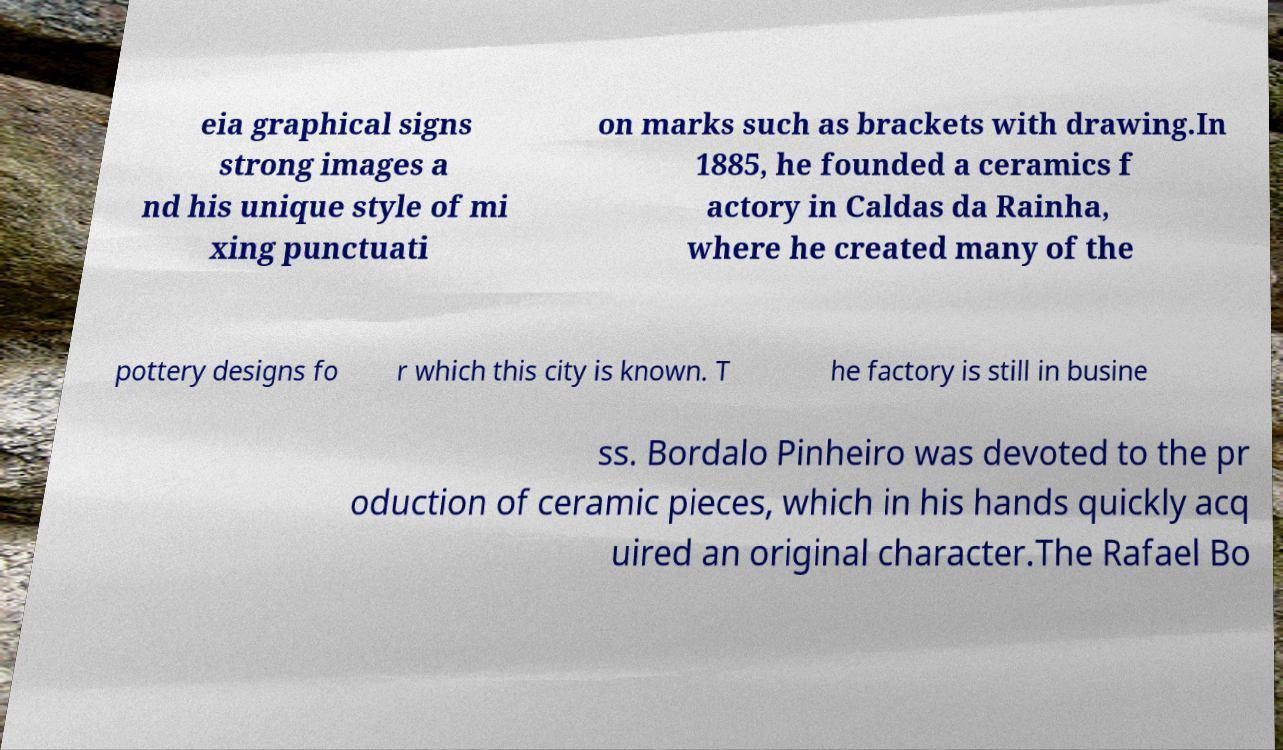What messages or text are displayed in this image? I need them in a readable, typed format. eia graphical signs strong images a nd his unique style of mi xing punctuati on marks such as brackets with drawing.In 1885, he founded a ceramics f actory in Caldas da Rainha, where he created many of the pottery designs fo r which this city is known. T he factory is still in busine ss. Bordalo Pinheiro was devoted to the pr oduction of ceramic pieces, which in his hands quickly acq uired an original character.The Rafael Bo 